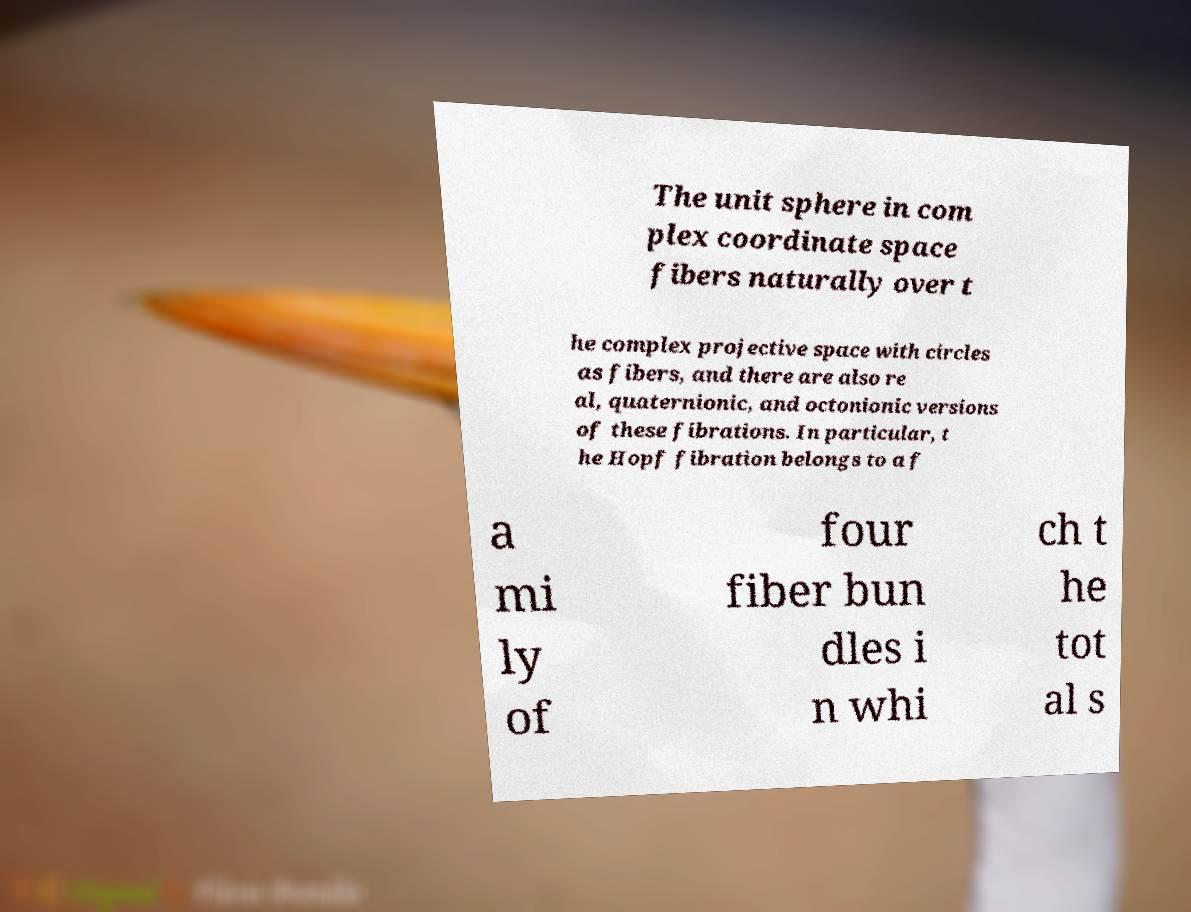For documentation purposes, I need the text within this image transcribed. Could you provide that? The unit sphere in com plex coordinate space fibers naturally over t he complex projective space with circles as fibers, and there are also re al, quaternionic, and octonionic versions of these fibrations. In particular, t he Hopf fibration belongs to a f a mi ly of four fiber bun dles i n whi ch t he tot al s 